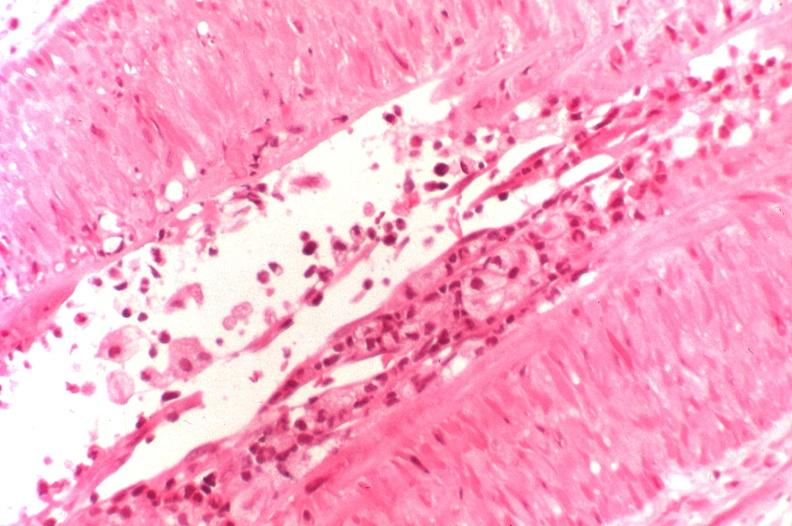what does this image show?
Answer the question using a single word or phrase. Kidney transplant rejection 